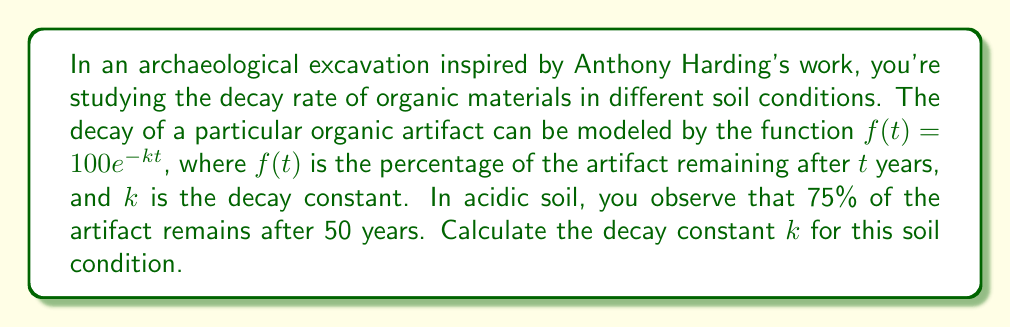What is the answer to this math problem? Let's approach this step-by-step:

1) We're given the decay function: $f(t) = 100e^{-kt}$

2) We know that after 50 years (t = 50), 75% of the artifact remains. We can express this as:

   $f(50) = 75$

3) Let's substitute these values into our original equation:

   $75 = 100e^{-k(50)}$

4) Divide both sides by 100:

   $0.75 = e^{-50k}$

5) Take the natural logarithm of both sides:

   $\ln(0.75) = \ln(e^{-50k})$

6) Simplify the right side using the properties of logarithms:

   $\ln(0.75) = -50k$

7) Solve for $k$:

   $k = -\frac{\ln(0.75)}{50}$

8) Calculate the value:

   $k = -\frac{\ln(0.75)}{50} \approx 0.00575$ per year
Answer: $k \approx 0.00575$ per year 